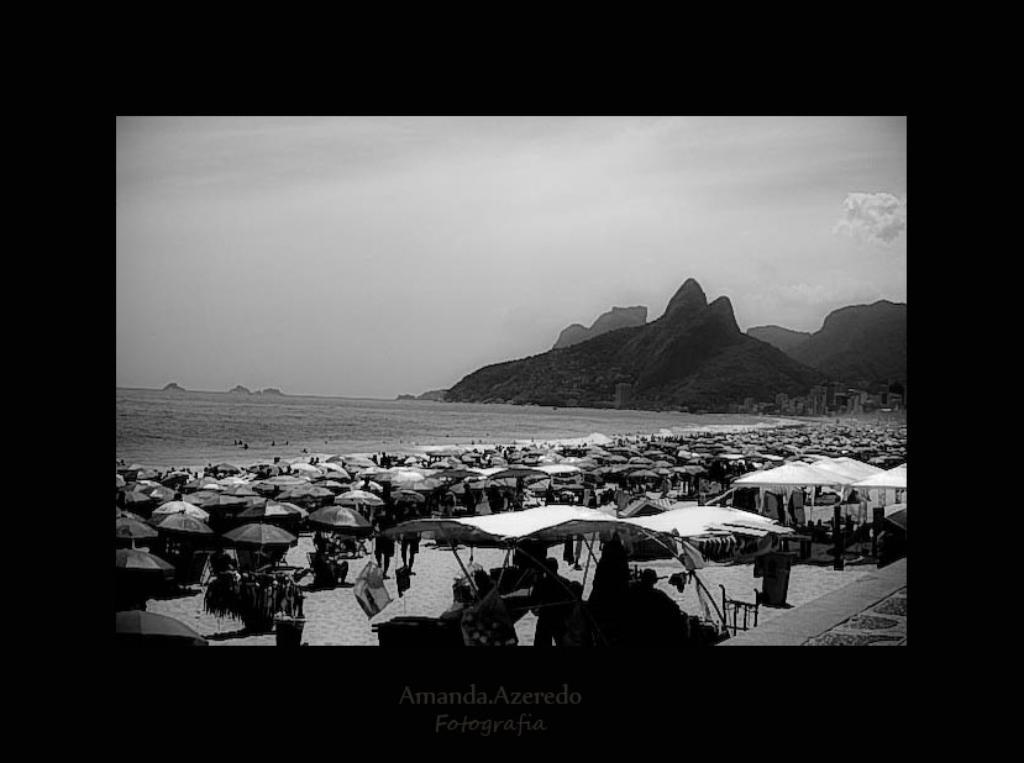What type of temporary shelters can be seen in the image? There are tents in the image. What objects are present for protection from the sun or rain? There are umbrellas in the image. Can you describe the people in the image? There is a group of people in the image. What can be seen in the distance in the image? There is water, hills, and clouds visible in the background of the image. Is there any text present in the image? Yes, there is some text at the bottom of the image. What type of acoustics can be heard from the guitar in the image? There is no guitar present in the image, so it is not possible to determine the acoustics. Can you tell me how many pets are visible in the image? There are no pets visible in the image. 